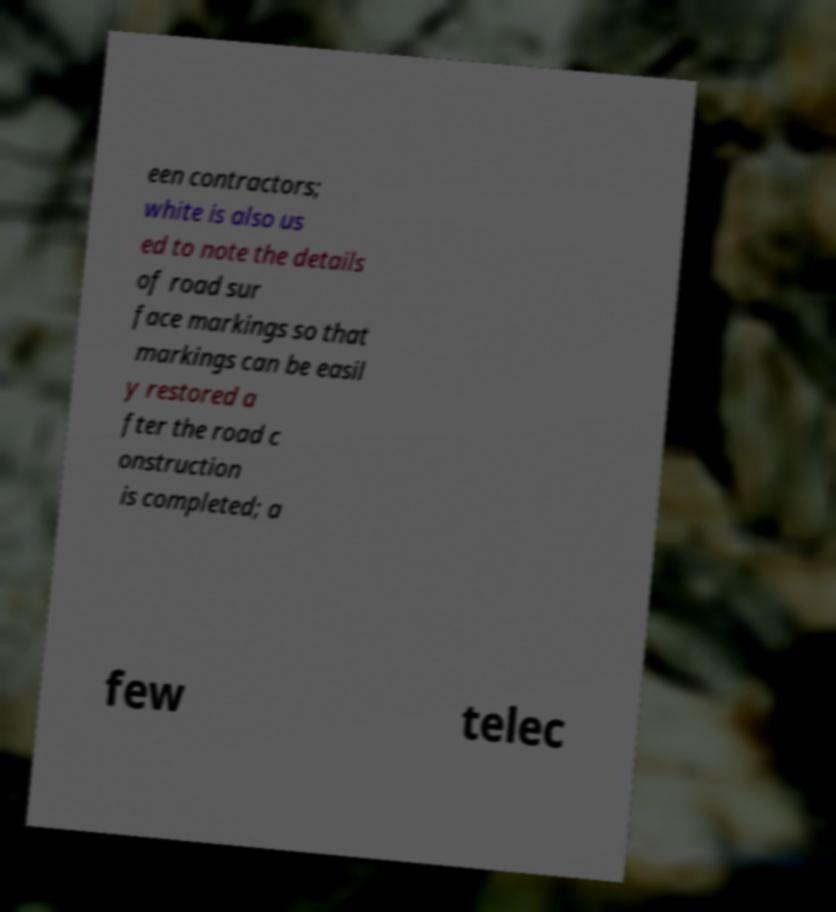There's text embedded in this image that I need extracted. Can you transcribe it verbatim? een contractors; white is also us ed to note the details of road sur face markings so that markings can be easil y restored a fter the road c onstruction is completed; a few telec 